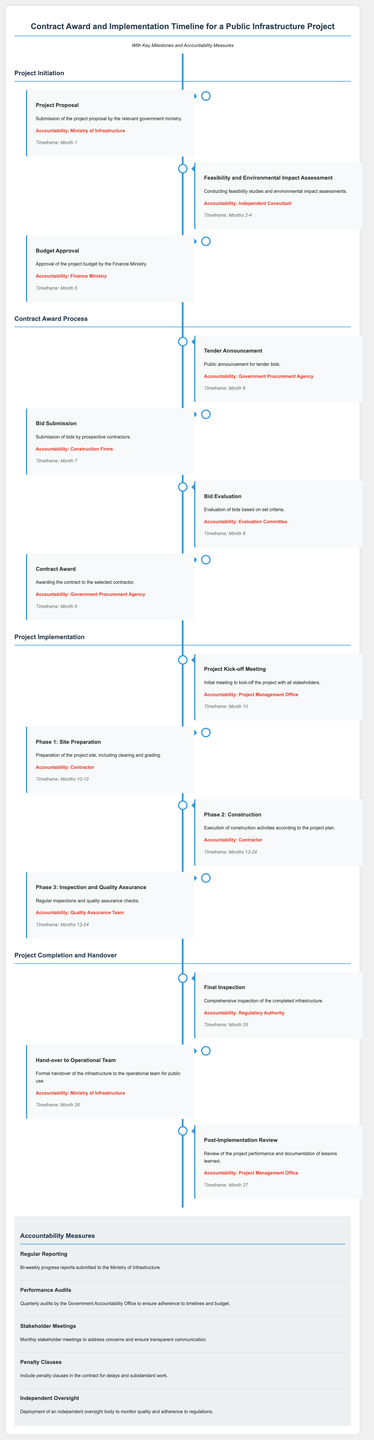What is the first milestone of the project? The first milestone is the submission of the project proposal by the relevant government ministry.
Answer: Project Proposal Who is accountable for the feasibility study? The accountability for conducting feasibility studies is assigned to an Independent Consultant.
Answer: Independent Consultant In which month does the contract get awarded? The contract is awarded in Month 9, according to the timeline presented in the document.
Answer: Month 9 How long is the Construction phase scheduled to last? The Construction phase lasts from Months 13 to 24, as outlined in the implementation timeline.
Answer: Months 13-24 What type of meetings are held monthly during the project? Monthly stakeholder meetings are scheduled to ensure transparent communication and address concerns.
Answer: Stakeholder Meetings Which authority conducts the final inspection? The final inspection is conducted by the Regulatory Authority, as mentioned in the accountability section.
Answer: Regulatory Authority What is included in the accountability measures for the project? One of the accountability measures includes the inclusion of penalty clauses in the contract for delays and substandard work.
Answer: Penalty Clauses What is the timeframe for the budget approval milestone? The timeframe indicated for budget approval is Month 5 in the project timeline.
Answer: Month 5 Which phase includes regular inspections? Phase 3 covers inspection and quality assurance, as stated in the project implementation section.
Answer: Phase 3: Inspection and Quality Assurance 